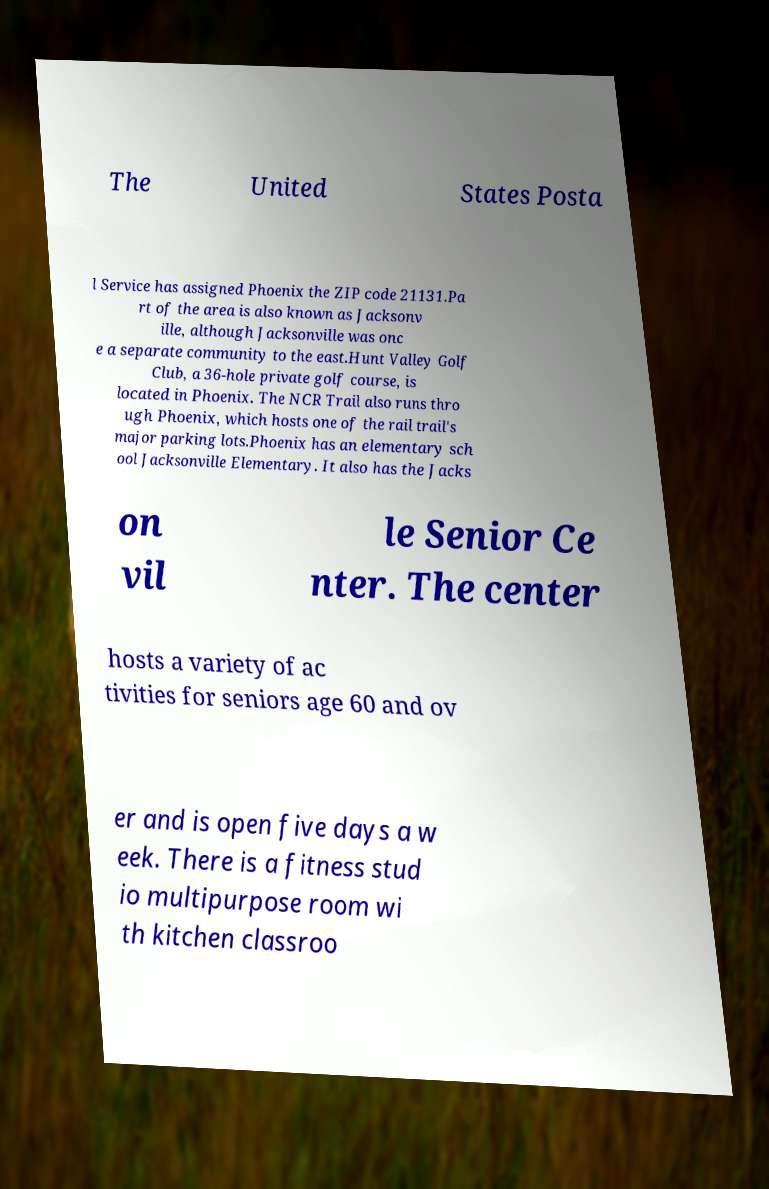Could you assist in decoding the text presented in this image and type it out clearly? The United States Posta l Service has assigned Phoenix the ZIP code 21131.Pa rt of the area is also known as Jacksonv ille, although Jacksonville was onc e a separate community to the east.Hunt Valley Golf Club, a 36-hole private golf course, is located in Phoenix. The NCR Trail also runs thro ugh Phoenix, which hosts one of the rail trail's major parking lots.Phoenix has an elementary sch ool Jacksonville Elementary. It also has the Jacks on vil le Senior Ce nter. The center hosts a variety of ac tivities for seniors age 60 and ov er and is open five days a w eek. There is a fitness stud io multipurpose room wi th kitchen classroo 